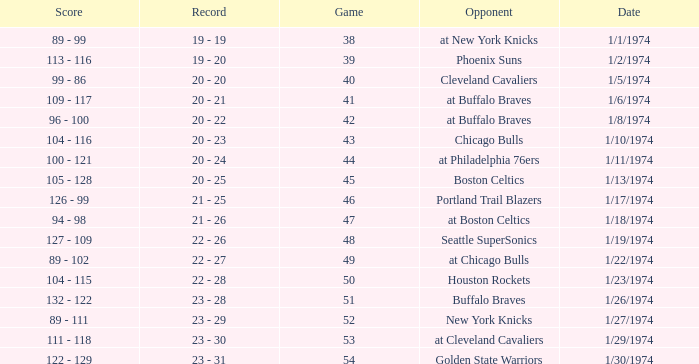What was the record after game 51 on 1/27/1974? 23 - 29. 